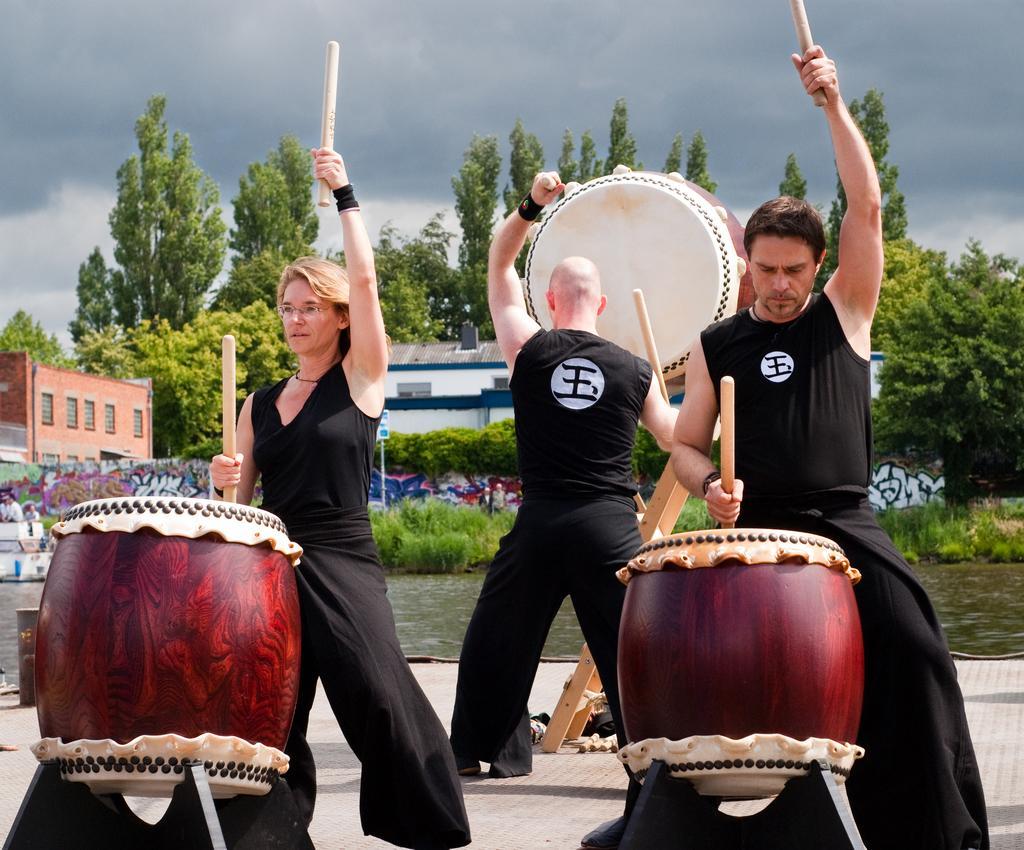Could you give a brief overview of what you see in this image? In this image we have a woman beating the drums,a man beating the drums another person beating the drums and at back ground we have trees, building , plants, pole, sky and water. 